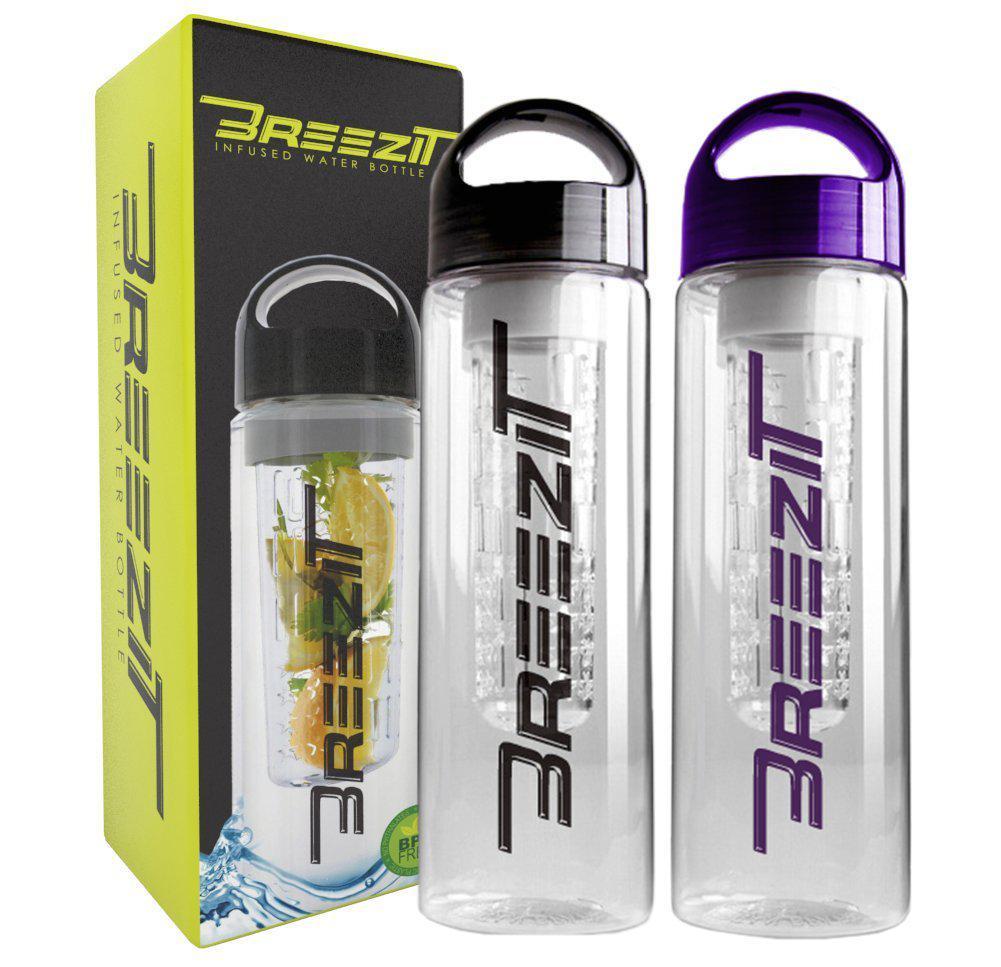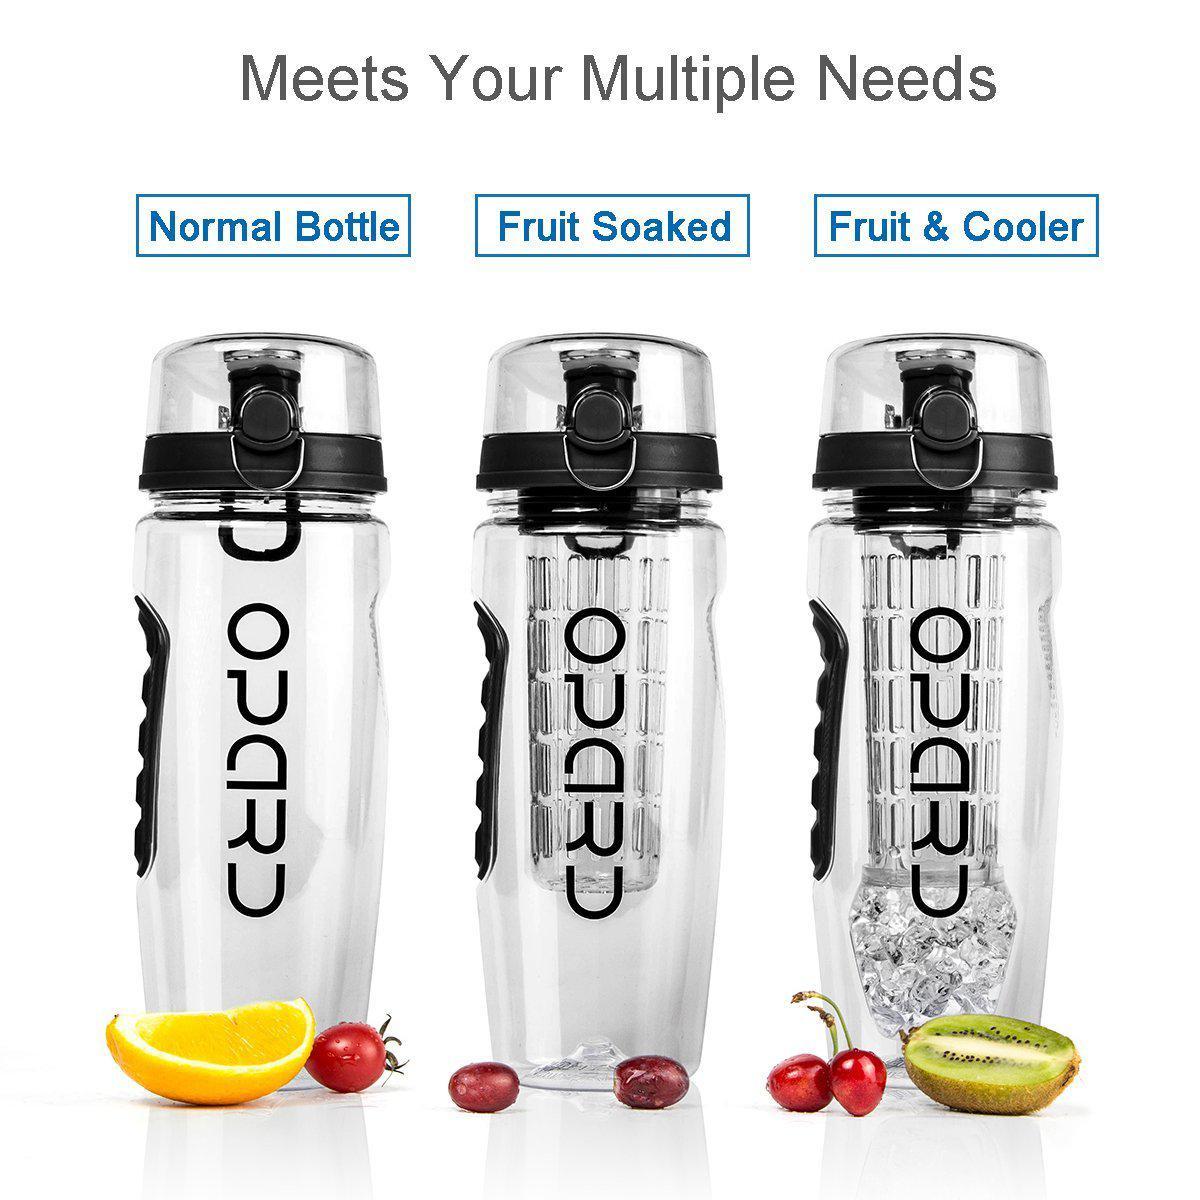The first image is the image on the left, the second image is the image on the right. Examine the images to the left and right. Is the description "An image shows three water bottles posed next to fruits." accurate? Answer yes or no. Yes. The first image is the image on the left, the second image is the image on the right. Evaluate the accuracy of this statement regarding the images: "Three clear containers stand in a line in one of the images.". Is it true? Answer yes or no. Yes. 